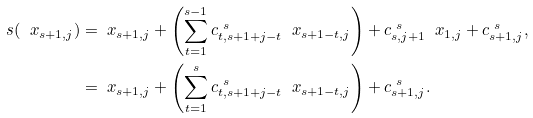<formula> <loc_0><loc_0><loc_500><loc_500>\ s ( \ x _ { s + 1 , j } ) & = \ x _ { s + 1 , j } + \left ( \sum ^ { s - 1 } _ { t = 1 } c ^ { \ s } _ { t , s + 1 + j - t } \ \ x _ { s + 1 - t , j } \right ) + c ^ { \ s } _ { s , j + 1 } \ \ x _ { 1 , j } + c ^ { \ s } _ { s + 1 , j } , \\ & = \ x _ { s + 1 , j } + \left ( \sum ^ { s } _ { t = 1 } c ^ { \ s } _ { t , s + 1 + j - t } \ \ x _ { s + 1 - t , j } \right ) + c ^ { \ s } _ { s + 1 , j } .</formula> 